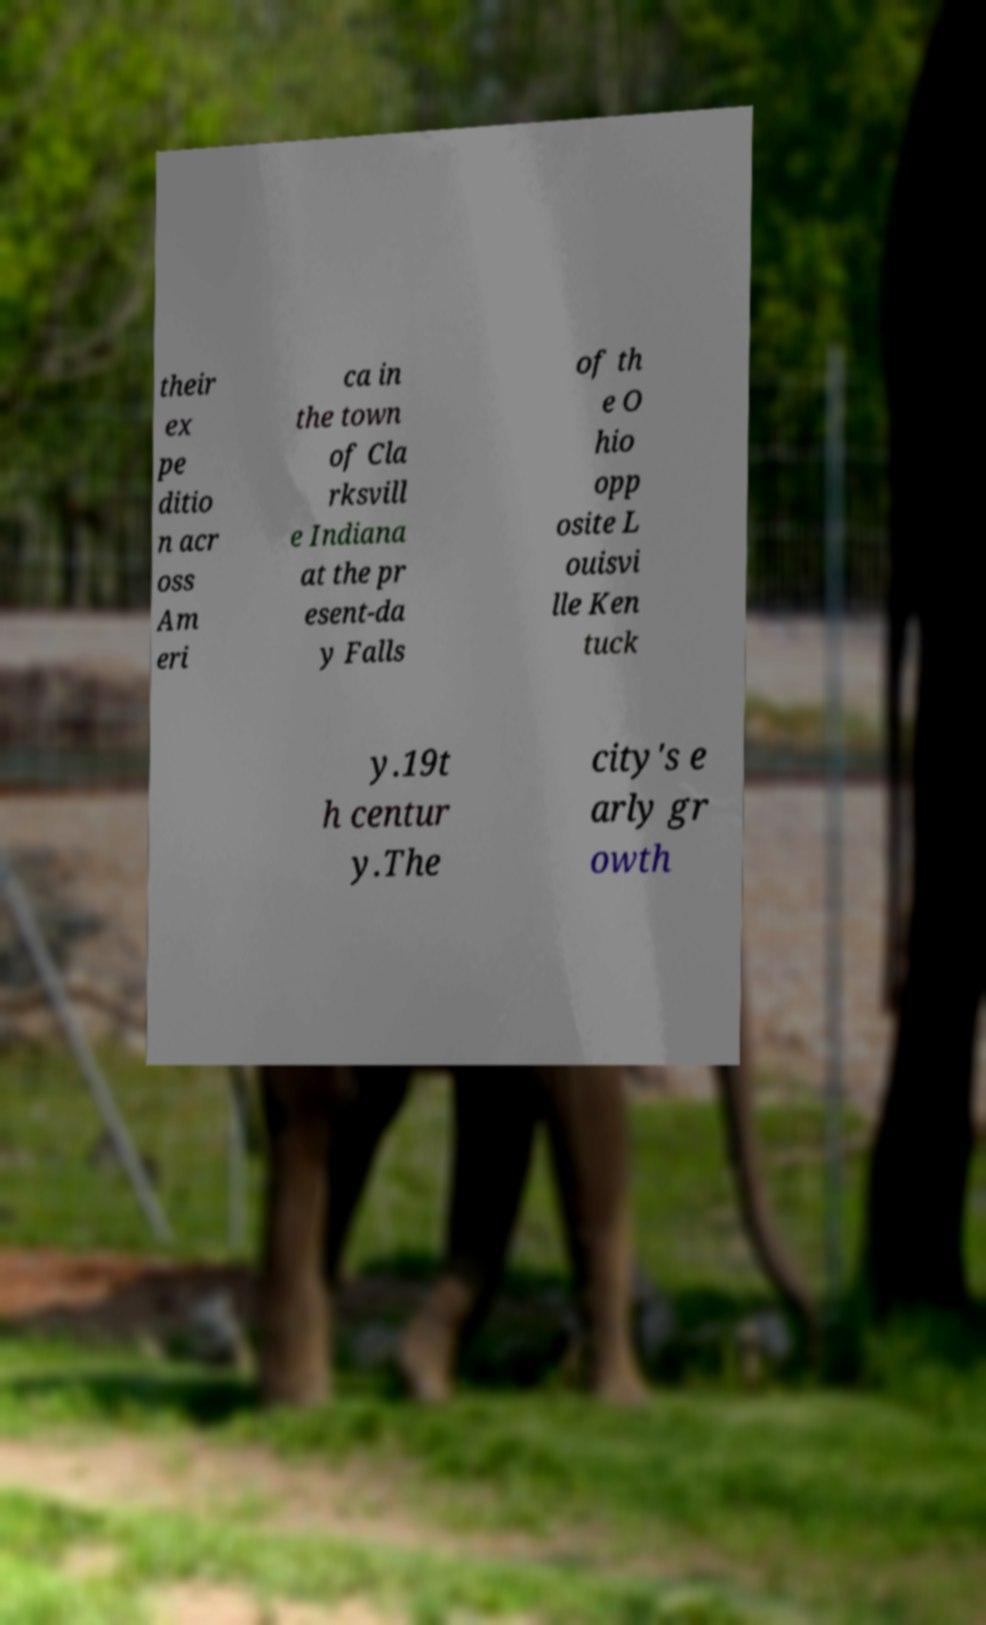I need the written content from this picture converted into text. Can you do that? their ex pe ditio n acr oss Am eri ca in the town of Cla rksvill e Indiana at the pr esent-da y Falls of th e O hio opp osite L ouisvi lle Ken tuck y.19t h centur y.The city's e arly gr owth 